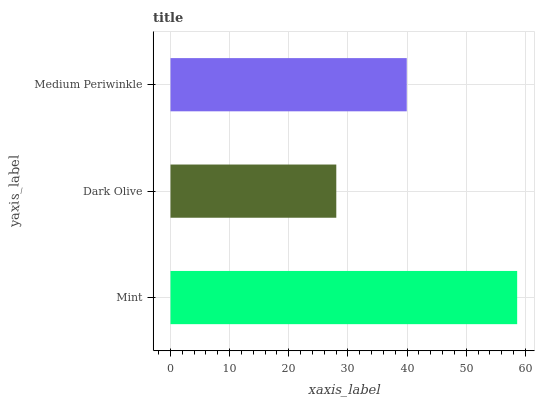Is Dark Olive the minimum?
Answer yes or no. Yes. Is Mint the maximum?
Answer yes or no. Yes. Is Medium Periwinkle the minimum?
Answer yes or no. No. Is Medium Periwinkle the maximum?
Answer yes or no. No. Is Medium Periwinkle greater than Dark Olive?
Answer yes or no. Yes. Is Dark Olive less than Medium Periwinkle?
Answer yes or no. Yes. Is Dark Olive greater than Medium Periwinkle?
Answer yes or no. No. Is Medium Periwinkle less than Dark Olive?
Answer yes or no. No. Is Medium Periwinkle the high median?
Answer yes or no. Yes. Is Medium Periwinkle the low median?
Answer yes or no. Yes. Is Mint the high median?
Answer yes or no. No. Is Mint the low median?
Answer yes or no. No. 